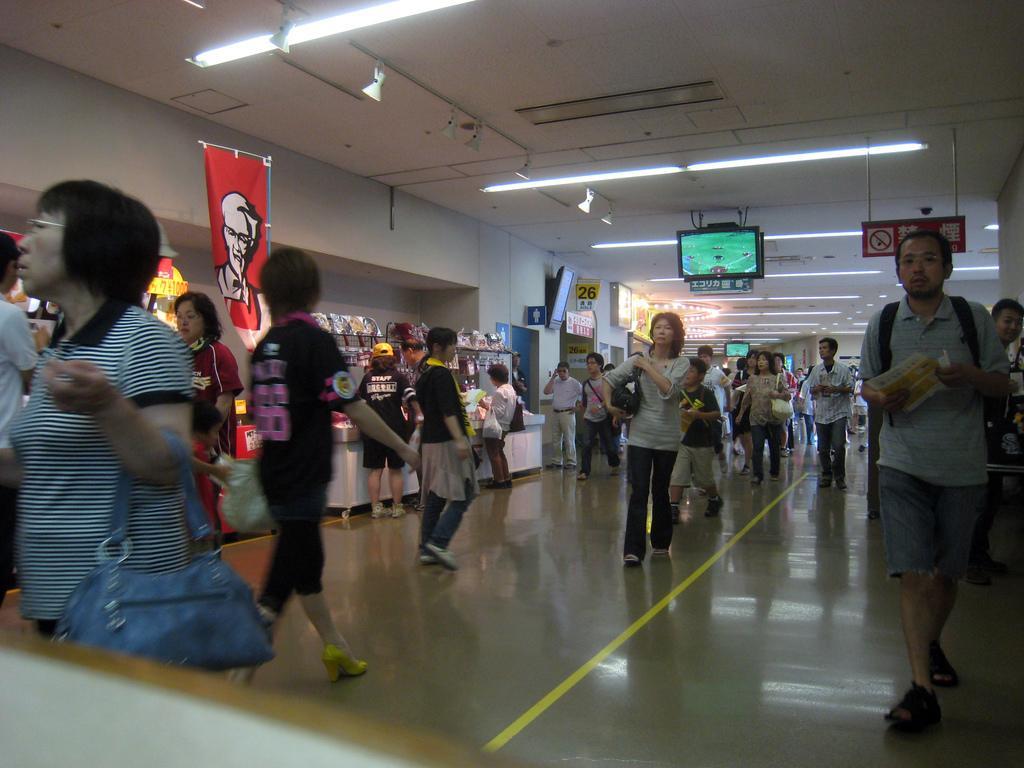Could you give a brief overview of what you see in this image? In this image we can see few people walking on the floor, a person is holding a paper and some of them are holding bags, there is a banner, few stalls and a wall with few boards on the left side and there is a screen and few boards hanged to the ceiling and there are lights attached to the ceiling. 